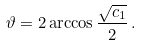<formula> <loc_0><loc_0><loc_500><loc_500>\vartheta = 2 \arccos \frac { \sqrt { c _ { 1 } } } { 2 } \, .</formula> 